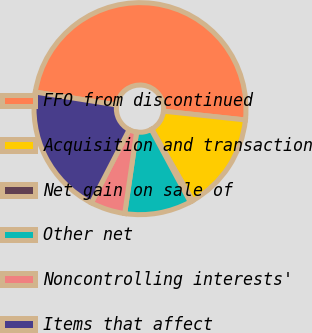Convert chart to OTSL. <chart><loc_0><loc_0><loc_500><loc_500><pie_chart><fcel>FFO from discontinued<fcel>Acquisition and transaction<fcel>Net gain on sale of<fcel>Other net<fcel>Noncontrolling interests'<fcel>Items that affect<nl><fcel>49.2%<fcel>15.04%<fcel>0.4%<fcel>10.16%<fcel>5.28%<fcel>19.92%<nl></chart> 